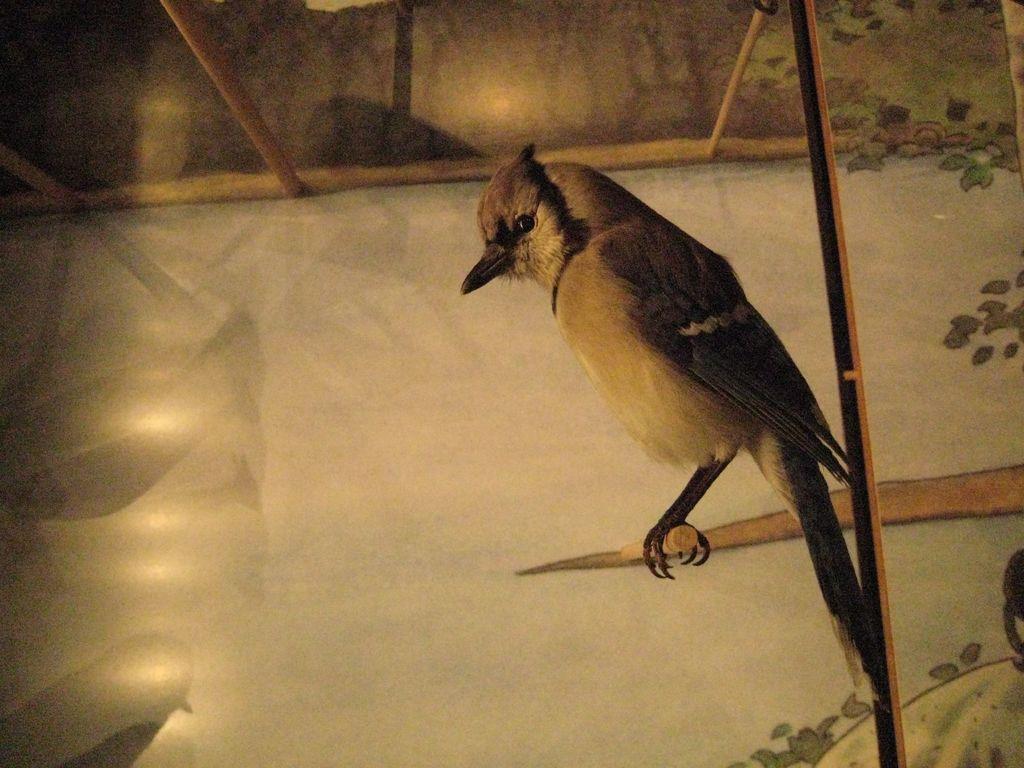Could you give a brief overview of what you see in this image? In this image we can see a bird on the stick. In the background there is a wall and we can see a painting on the wall. At the top there are sticks. 